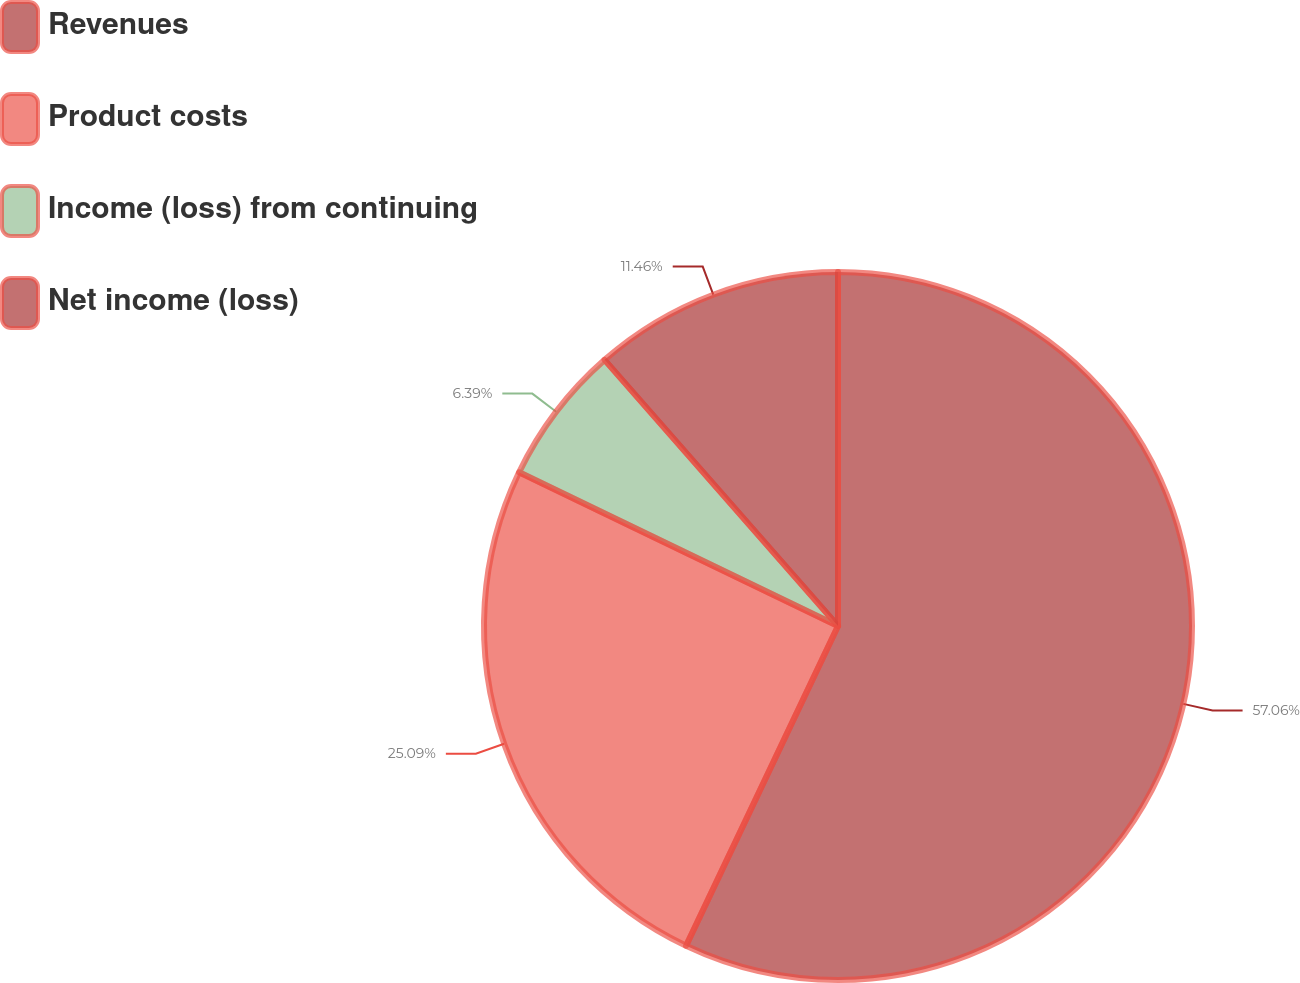Convert chart. <chart><loc_0><loc_0><loc_500><loc_500><pie_chart><fcel>Revenues<fcel>Product costs<fcel>Income (loss) from continuing<fcel>Net income (loss)<nl><fcel>57.06%<fcel>25.09%<fcel>6.39%<fcel>11.46%<nl></chart> 